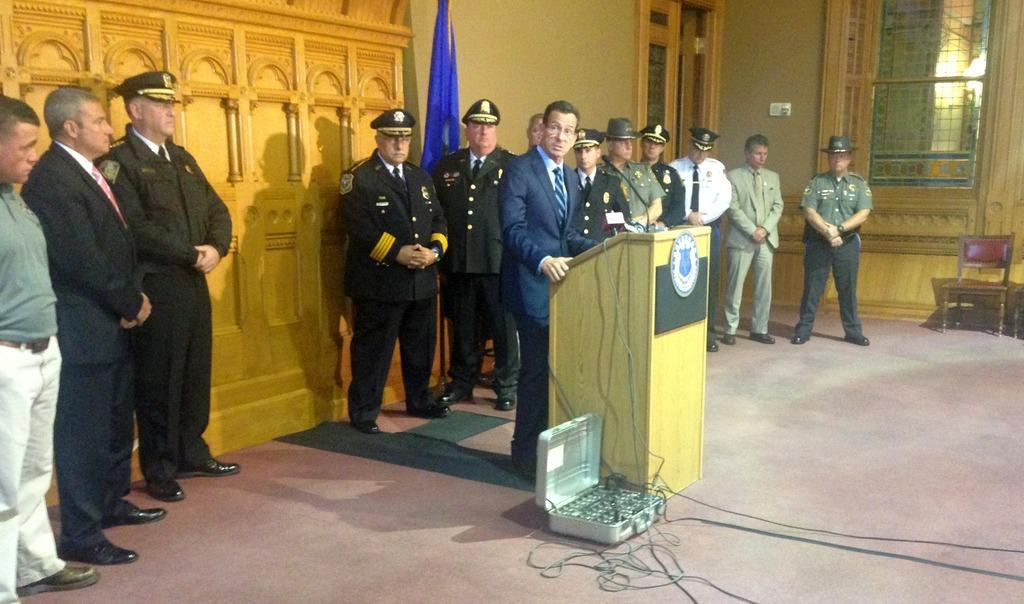How many men are present in the image? There are men standing in the image. What is the position of one of the men in relation to the podium? One of the men is standing in front of a podium. What can be seen in the background of the image? There is a wall visible in the background of the image. What type of wound can be seen on the ship in the image? There is no ship present in the image, and therefore no wound can be observed. What type of vase is visible on the wall in the image? There is no vase visible on the wall in the image. 